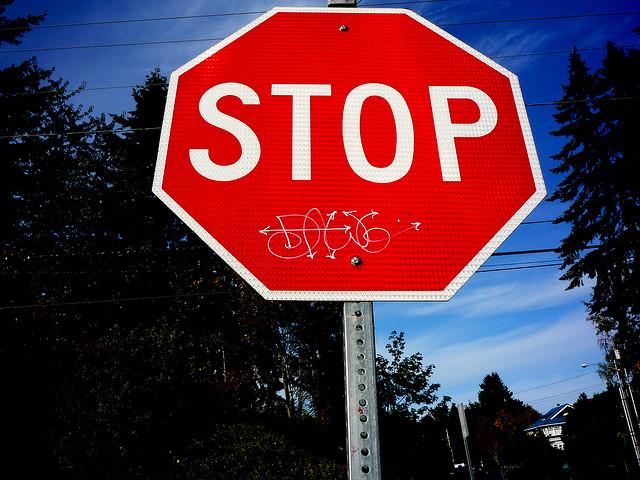What is the sign attached to?
Give a very brief answer. Pole. What is the text on the sign?
Short answer required. Stop. What does the graffiti say?
Concise answer only. Dog. Where on the sign is the graffiti?
Write a very short answer. Bottom. 